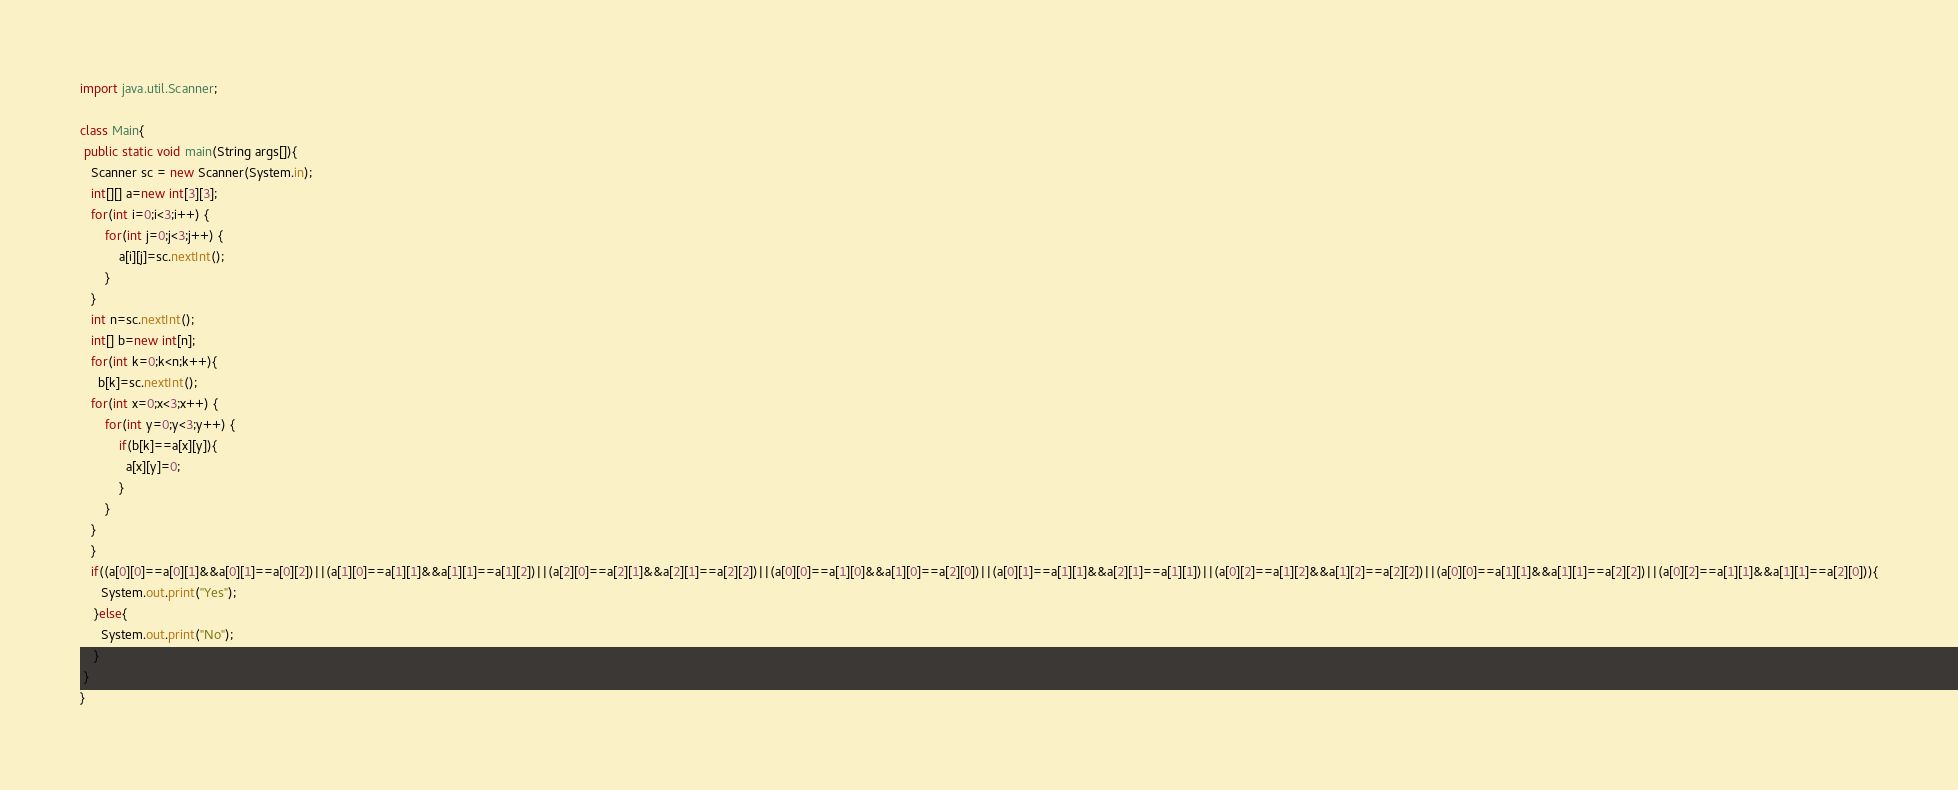Convert code to text. <code><loc_0><loc_0><loc_500><loc_500><_Java_>import java.util.Scanner;
 
class Main{
 public static void main(String args[]){
   Scanner sc = new Scanner(System.in);
   int[][] a=new int[3][3];
   for(int i=0;i<3;i++) {
	   for(int j=0;j<3;j++) {
		   a[i][j]=sc.nextInt();
	   }
   }
   int n=sc.nextInt();
   int[] b=new int[n];
   for(int k=0;k<n;k++){
     b[k]=sc.nextInt();
   for(int x=0;x<3;x++) {
	   for(int y=0;y<3;y++) {
		   if(b[k]==a[x][y]){
             a[x][y]=0;
           }
	   }
   }
   }
   if((a[0][0]==a[0][1]&&a[0][1]==a[0][2])||(a[1][0]==a[1][1]&&a[1][1]==a[1][2])||(a[2][0]==a[2][1]&&a[2][1]==a[2][2])||(a[0][0]==a[1][0]&&a[1][0]==a[2][0])||(a[0][1]==a[1][1]&&a[2][1]==a[1][1])||(a[0][2]==a[1][2]&&a[1][2]==a[2][2])||(a[0][0]==a[1][1]&&a[1][1]==a[2][2])||(a[0][2]==a[1][1]&&a[1][1]==a[2][0])){
      System.out.print("Yes");
    }else{
      System.out.print("No");
    }
 }
}
</code> 